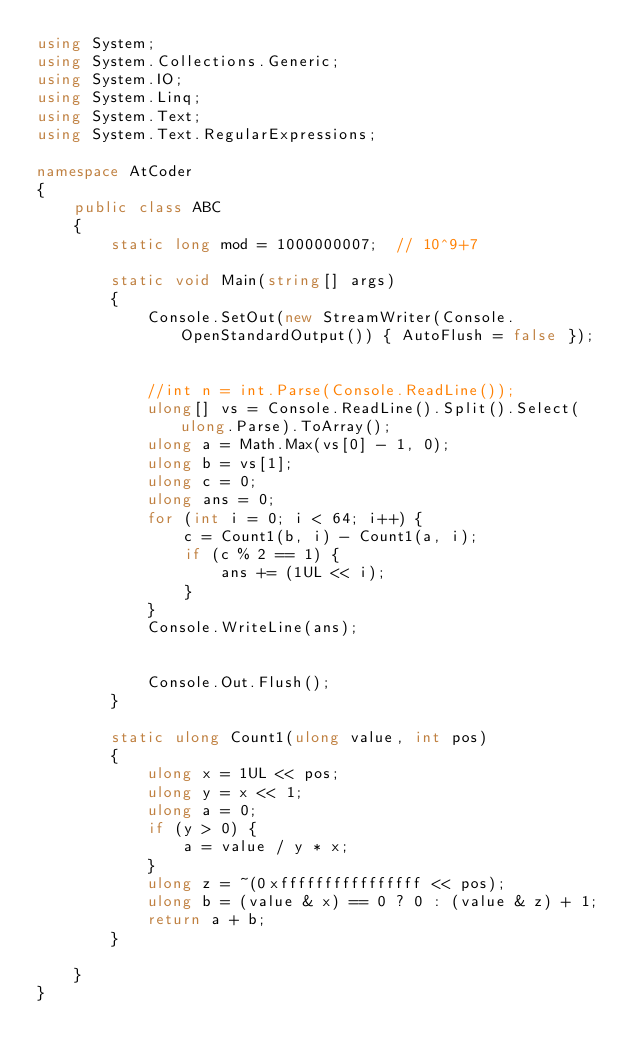<code> <loc_0><loc_0><loc_500><loc_500><_C#_>using System;
using System.Collections.Generic;
using System.IO;
using System.Linq;
using System.Text;
using System.Text.RegularExpressions;

namespace AtCoder
{
	public class ABC
	{
		static long mod = 1000000007;  // 10^9+7

		static void Main(string[] args)
		{
			Console.SetOut(new StreamWriter(Console.OpenStandardOutput()) { AutoFlush = false });


			//int n = int.Parse(Console.ReadLine());
			ulong[] vs = Console.ReadLine().Split().Select(ulong.Parse).ToArray();
			ulong a = Math.Max(vs[0] - 1, 0);
			ulong b = vs[1];
			ulong c = 0;
			ulong ans = 0;
			for (int i = 0; i < 64; i++) {
				c = Count1(b, i) - Count1(a, i);
				if (c % 2 == 1) {
					ans += (1UL << i);
				}
			}
			Console.WriteLine(ans);


			Console.Out.Flush();
		}

		static ulong Count1(ulong value, int pos)
		{
			ulong x = 1UL << pos;
			ulong y = x << 1;
			ulong a = 0;
			if (y > 0) {
				a = value / y * x;
			}
			ulong z = ~(0xffffffffffffffff << pos);
			ulong b = (value & x) == 0 ? 0 : (value & z) + 1;
			return a + b;
		}

	}
}
</code> 